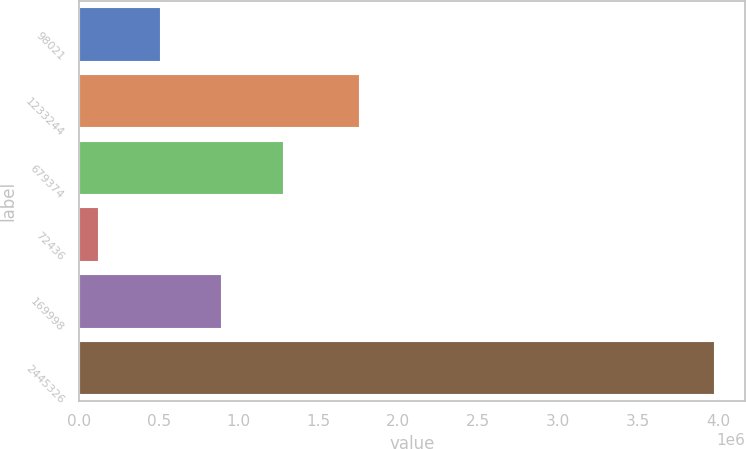Convert chart. <chart><loc_0><loc_0><loc_500><loc_500><bar_chart><fcel>98021<fcel>1233244<fcel>679374<fcel>72436<fcel>169998<fcel>2445326<nl><fcel>507778<fcel>1.75186e+06<fcel>1.27743e+06<fcel>122954<fcel>892601<fcel>3.97119e+06<nl></chart> 